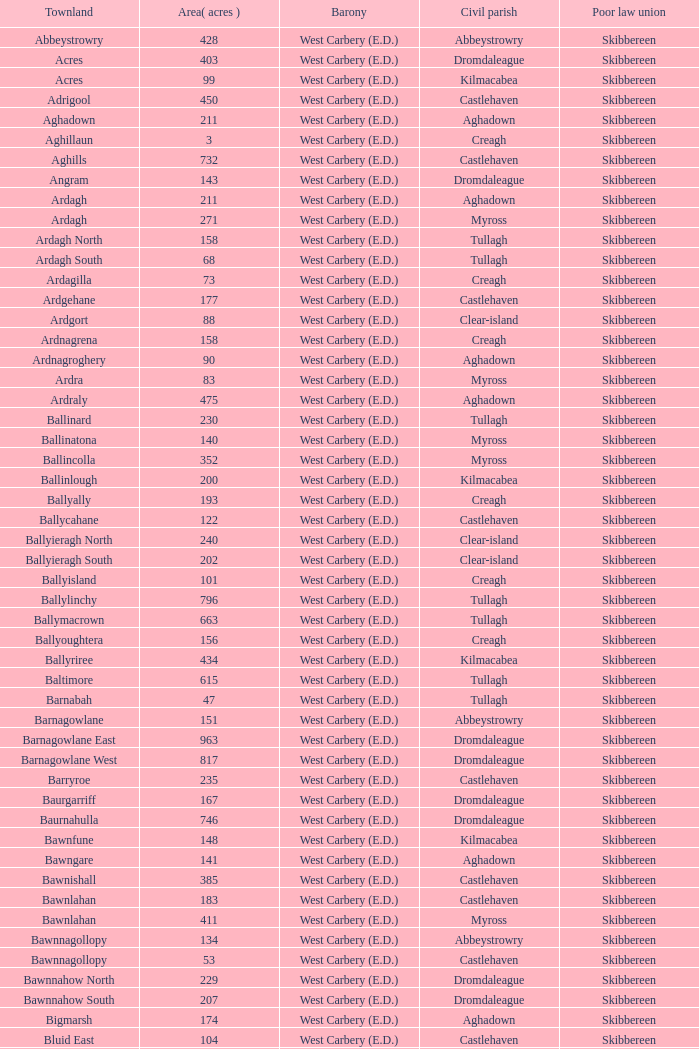What are the Baronies when the area (in acres) is 276? West Carbery (E.D.). 